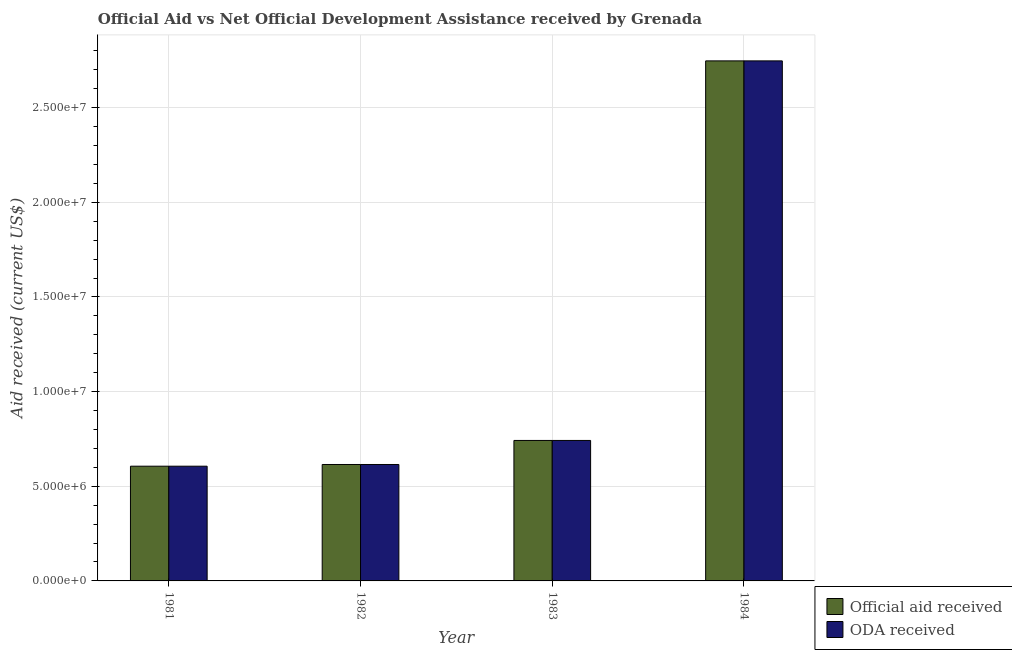How many bars are there on the 4th tick from the left?
Your response must be concise. 2. What is the label of the 4th group of bars from the left?
Make the answer very short. 1984. In how many cases, is the number of bars for a given year not equal to the number of legend labels?
Provide a short and direct response. 0. What is the oda received in 1984?
Make the answer very short. 2.75e+07. Across all years, what is the maximum official aid received?
Give a very brief answer. 2.75e+07. Across all years, what is the minimum official aid received?
Your answer should be very brief. 6.06e+06. In which year was the oda received maximum?
Provide a succinct answer. 1984. In which year was the oda received minimum?
Your response must be concise. 1981. What is the total oda received in the graph?
Offer a very short reply. 4.71e+07. What is the difference between the official aid received in 1981 and that in 1983?
Keep it short and to the point. -1.36e+06. What is the difference between the oda received in 1982 and the official aid received in 1983?
Ensure brevity in your answer.  -1.27e+06. What is the average official aid received per year?
Keep it short and to the point. 1.18e+07. In the year 1984, what is the difference between the official aid received and oda received?
Your answer should be very brief. 0. In how many years, is the official aid received greater than 11000000 US$?
Ensure brevity in your answer.  1. What is the ratio of the official aid received in 1981 to that in 1982?
Your answer should be compact. 0.99. What is the difference between the highest and the second highest official aid received?
Your answer should be compact. 2.00e+07. What is the difference between the highest and the lowest oda received?
Your answer should be very brief. 2.14e+07. In how many years, is the official aid received greater than the average official aid received taken over all years?
Ensure brevity in your answer.  1. Is the sum of the oda received in 1981 and 1983 greater than the maximum official aid received across all years?
Your response must be concise. No. What does the 2nd bar from the left in 1982 represents?
Provide a short and direct response. ODA received. What does the 1st bar from the right in 1981 represents?
Your answer should be compact. ODA received. How many years are there in the graph?
Offer a terse response. 4. What is the difference between two consecutive major ticks on the Y-axis?
Your response must be concise. 5.00e+06. Does the graph contain grids?
Provide a succinct answer. Yes. How many legend labels are there?
Your answer should be compact. 2. How are the legend labels stacked?
Your answer should be compact. Vertical. What is the title of the graph?
Offer a very short reply. Official Aid vs Net Official Development Assistance received by Grenada . What is the label or title of the X-axis?
Ensure brevity in your answer.  Year. What is the label or title of the Y-axis?
Your answer should be very brief. Aid received (current US$). What is the Aid received (current US$) in Official aid received in 1981?
Offer a very short reply. 6.06e+06. What is the Aid received (current US$) of ODA received in 1981?
Offer a terse response. 6.06e+06. What is the Aid received (current US$) in Official aid received in 1982?
Your response must be concise. 6.15e+06. What is the Aid received (current US$) of ODA received in 1982?
Provide a succinct answer. 6.15e+06. What is the Aid received (current US$) of Official aid received in 1983?
Ensure brevity in your answer.  7.42e+06. What is the Aid received (current US$) in ODA received in 1983?
Your response must be concise. 7.42e+06. What is the Aid received (current US$) of Official aid received in 1984?
Your answer should be very brief. 2.75e+07. What is the Aid received (current US$) in ODA received in 1984?
Make the answer very short. 2.75e+07. Across all years, what is the maximum Aid received (current US$) of Official aid received?
Your response must be concise. 2.75e+07. Across all years, what is the maximum Aid received (current US$) in ODA received?
Your response must be concise. 2.75e+07. Across all years, what is the minimum Aid received (current US$) in Official aid received?
Provide a succinct answer. 6.06e+06. Across all years, what is the minimum Aid received (current US$) in ODA received?
Your answer should be compact. 6.06e+06. What is the total Aid received (current US$) in Official aid received in the graph?
Provide a succinct answer. 4.71e+07. What is the total Aid received (current US$) in ODA received in the graph?
Ensure brevity in your answer.  4.71e+07. What is the difference between the Aid received (current US$) of Official aid received in 1981 and that in 1982?
Give a very brief answer. -9.00e+04. What is the difference between the Aid received (current US$) in ODA received in 1981 and that in 1982?
Offer a very short reply. -9.00e+04. What is the difference between the Aid received (current US$) in Official aid received in 1981 and that in 1983?
Provide a short and direct response. -1.36e+06. What is the difference between the Aid received (current US$) of ODA received in 1981 and that in 1983?
Make the answer very short. -1.36e+06. What is the difference between the Aid received (current US$) in Official aid received in 1981 and that in 1984?
Keep it short and to the point. -2.14e+07. What is the difference between the Aid received (current US$) in ODA received in 1981 and that in 1984?
Your answer should be very brief. -2.14e+07. What is the difference between the Aid received (current US$) of Official aid received in 1982 and that in 1983?
Keep it short and to the point. -1.27e+06. What is the difference between the Aid received (current US$) in ODA received in 1982 and that in 1983?
Your answer should be compact. -1.27e+06. What is the difference between the Aid received (current US$) of Official aid received in 1982 and that in 1984?
Your answer should be very brief. -2.13e+07. What is the difference between the Aid received (current US$) in ODA received in 1982 and that in 1984?
Keep it short and to the point. -2.13e+07. What is the difference between the Aid received (current US$) of Official aid received in 1983 and that in 1984?
Provide a short and direct response. -2.00e+07. What is the difference between the Aid received (current US$) of ODA received in 1983 and that in 1984?
Give a very brief answer. -2.00e+07. What is the difference between the Aid received (current US$) of Official aid received in 1981 and the Aid received (current US$) of ODA received in 1983?
Ensure brevity in your answer.  -1.36e+06. What is the difference between the Aid received (current US$) of Official aid received in 1981 and the Aid received (current US$) of ODA received in 1984?
Your answer should be compact. -2.14e+07. What is the difference between the Aid received (current US$) in Official aid received in 1982 and the Aid received (current US$) in ODA received in 1983?
Provide a succinct answer. -1.27e+06. What is the difference between the Aid received (current US$) of Official aid received in 1982 and the Aid received (current US$) of ODA received in 1984?
Offer a terse response. -2.13e+07. What is the difference between the Aid received (current US$) in Official aid received in 1983 and the Aid received (current US$) in ODA received in 1984?
Your answer should be very brief. -2.00e+07. What is the average Aid received (current US$) of Official aid received per year?
Ensure brevity in your answer.  1.18e+07. What is the average Aid received (current US$) of ODA received per year?
Your answer should be very brief. 1.18e+07. In the year 1981, what is the difference between the Aid received (current US$) of Official aid received and Aid received (current US$) of ODA received?
Offer a very short reply. 0. In the year 1982, what is the difference between the Aid received (current US$) in Official aid received and Aid received (current US$) in ODA received?
Provide a succinct answer. 0. What is the ratio of the Aid received (current US$) of Official aid received in 1981 to that in 1982?
Your answer should be compact. 0.99. What is the ratio of the Aid received (current US$) of ODA received in 1981 to that in 1982?
Keep it short and to the point. 0.99. What is the ratio of the Aid received (current US$) of Official aid received in 1981 to that in 1983?
Offer a very short reply. 0.82. What is the ratio of the Aid received (current US$) of ODA received in 1981 to that in 1983?
Your answer should be compact. 0.82. What is the ratio of the Aid received (current US$) in Official aid received in 1981 to that in 1984?
Provide a short and direct response. 0.22. What is the ratio of the Aid received (current US$) of ODA received in 1981 to that in 1984?
Keep it short and to the point. 0.22. What is the ratio of the Aid received (current US$) in Official aid received in 1982 to that in 1983?
Offer a very short reply. 0.83. What is the ratio of the Aid received (current US$) of ODA received in 1982 to that in 1983?
Your response must be concise. 0.83. What is the ratio of the Aid received (current US$) of Official aid received in 1982 to that in 1984?
Offer a terse response. 0.22. What is the ratio of the Aid received (current US$) of ODA received in 1982 to that in 1984?
Your response must be concise. 0.22. What is the ratio of the Aid received (current US$) of Official aid received in 1983 to that in 1984?
Offer a terse response. 0.27. What is the ratio of the Aid received (current US$) of ODA received in 1983 to that in 1984?
Make the answer very short. 0.27. What is the difference between the highest and the second highest Aid received (current US$) in Official aid received?
Offer a terse response. 2.00e+07. What is the difference between the highest and the second highest Aid received (current US$) in ODA received?
Ensure brevity in your answer.  2.00e+07. What is the difference between the highest and the lowest Aid received (current US$) in Official aid received?
Keep it short and to the point. 2.14e+07. What is the difference between the highest and the lowest Aid received (current US$) of ODA received?
Offer a terse response. 2.14e+07. 